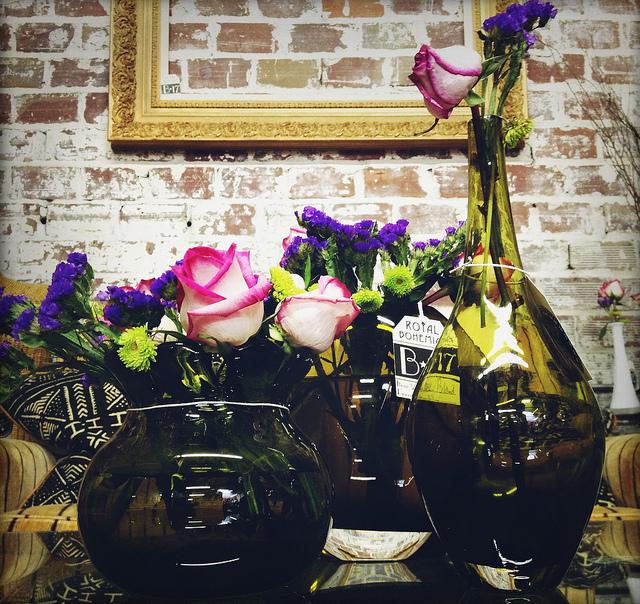What color is the glass?
Give a very brief answer. Green. Does the vase contain fresh flowers?
Keep it brief. Yes. Are the bottles broken?
Quick response, please. No. 